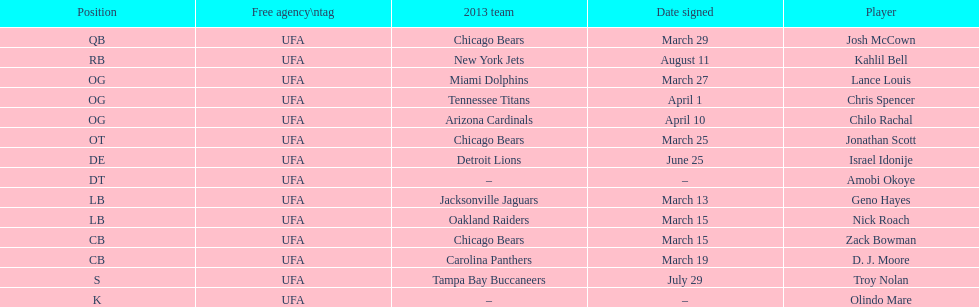Geno hayes and nick roach both played which position? LB. 